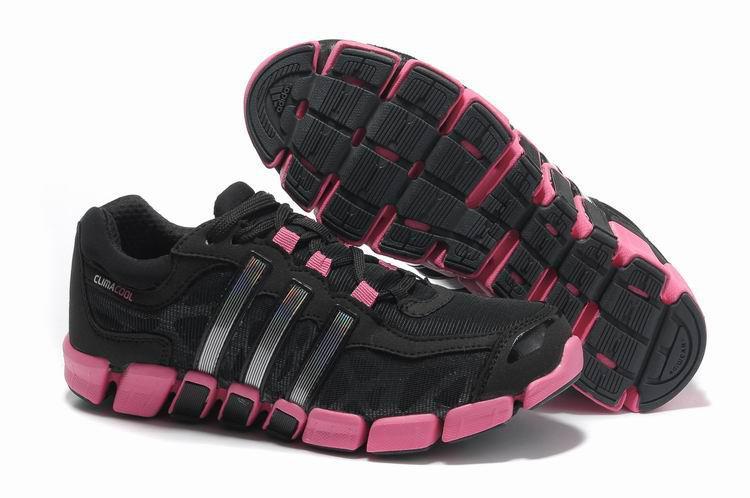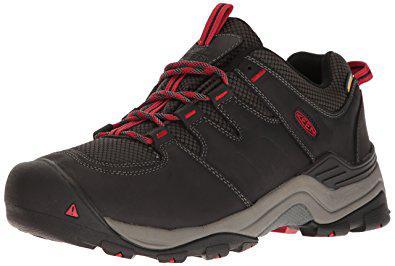The first image is the image on the left, the second image is the image on the right. Analyze the images presented: Is the assertion "All shoes feature hot pink and gray in their design, and all shoes have a curved boomerang-shaped logo on the side." valid? Answer yes or no. No. The first image is the image on the left, the second image is the image on the right. Assess this claim about the two images: "In one image a shoe is flipped on its side.". Correct or not? Answer yes or no. Yes. 